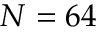<formula> <loc_0><loc_0><loc_500><loc_500>N = 6 4</formula> 